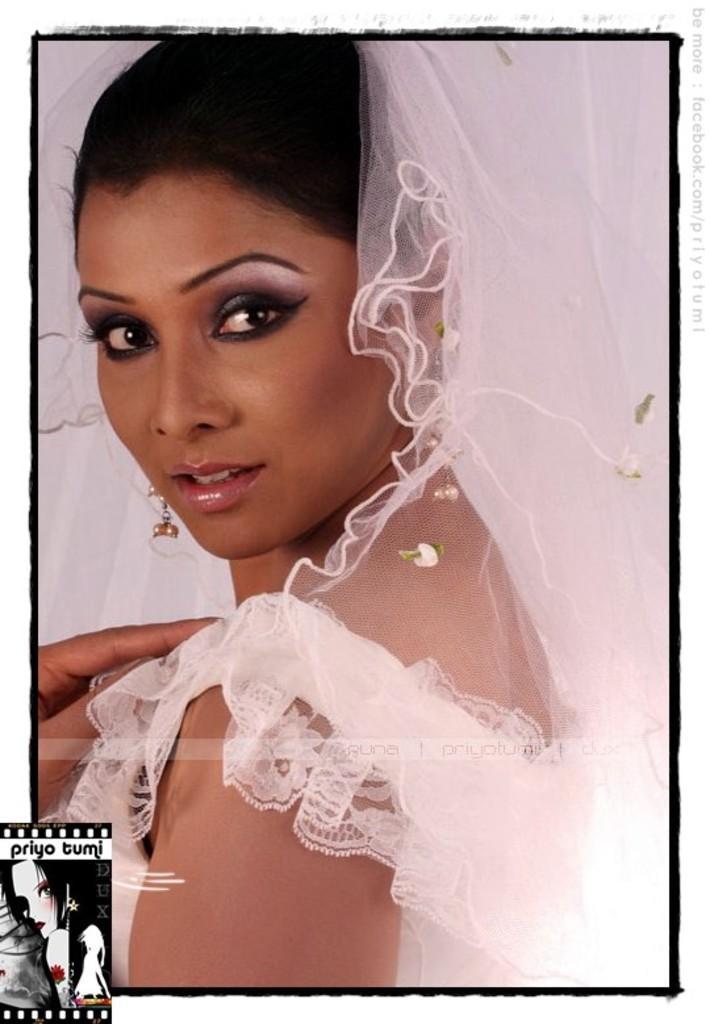Could you give a brief overview of what you see in this image? In this image we can see a lady wearing a white dress. 